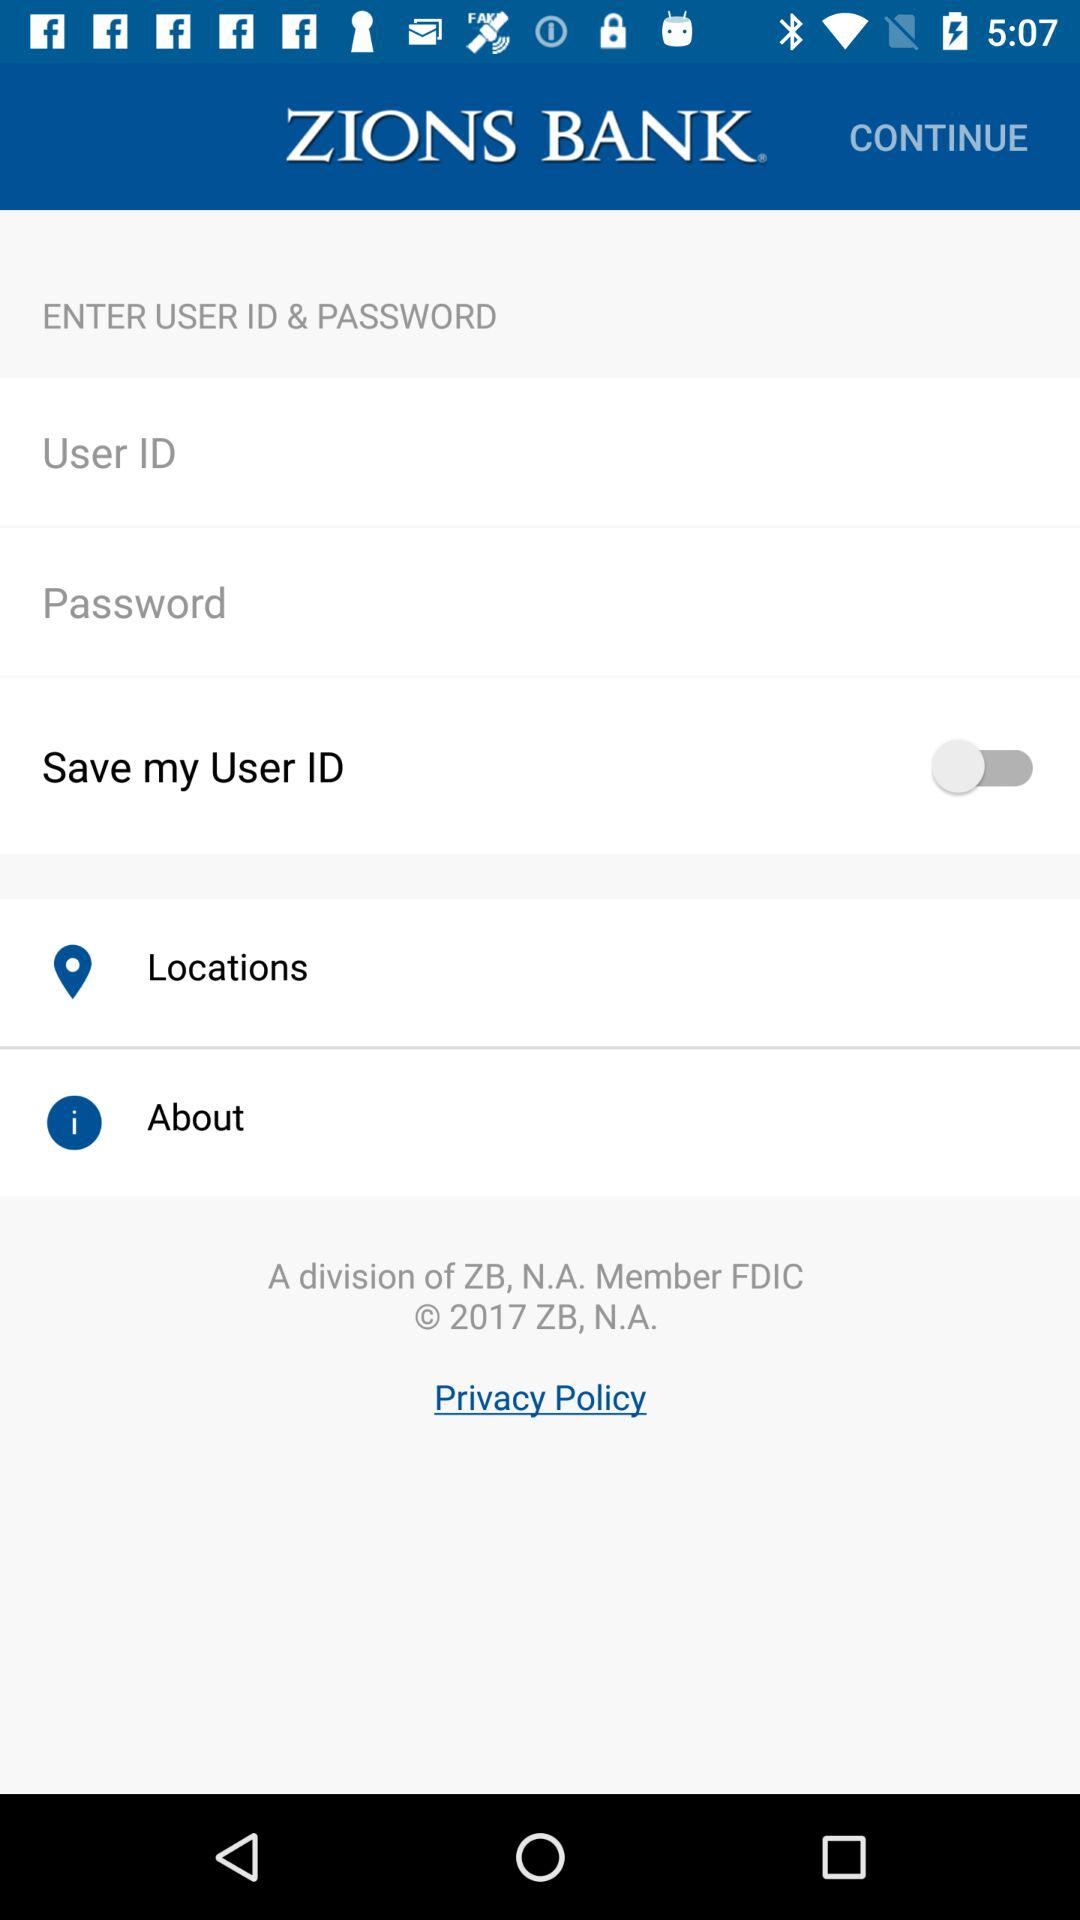What is the name of the application? The name of the application is "ZIONS BANK". 